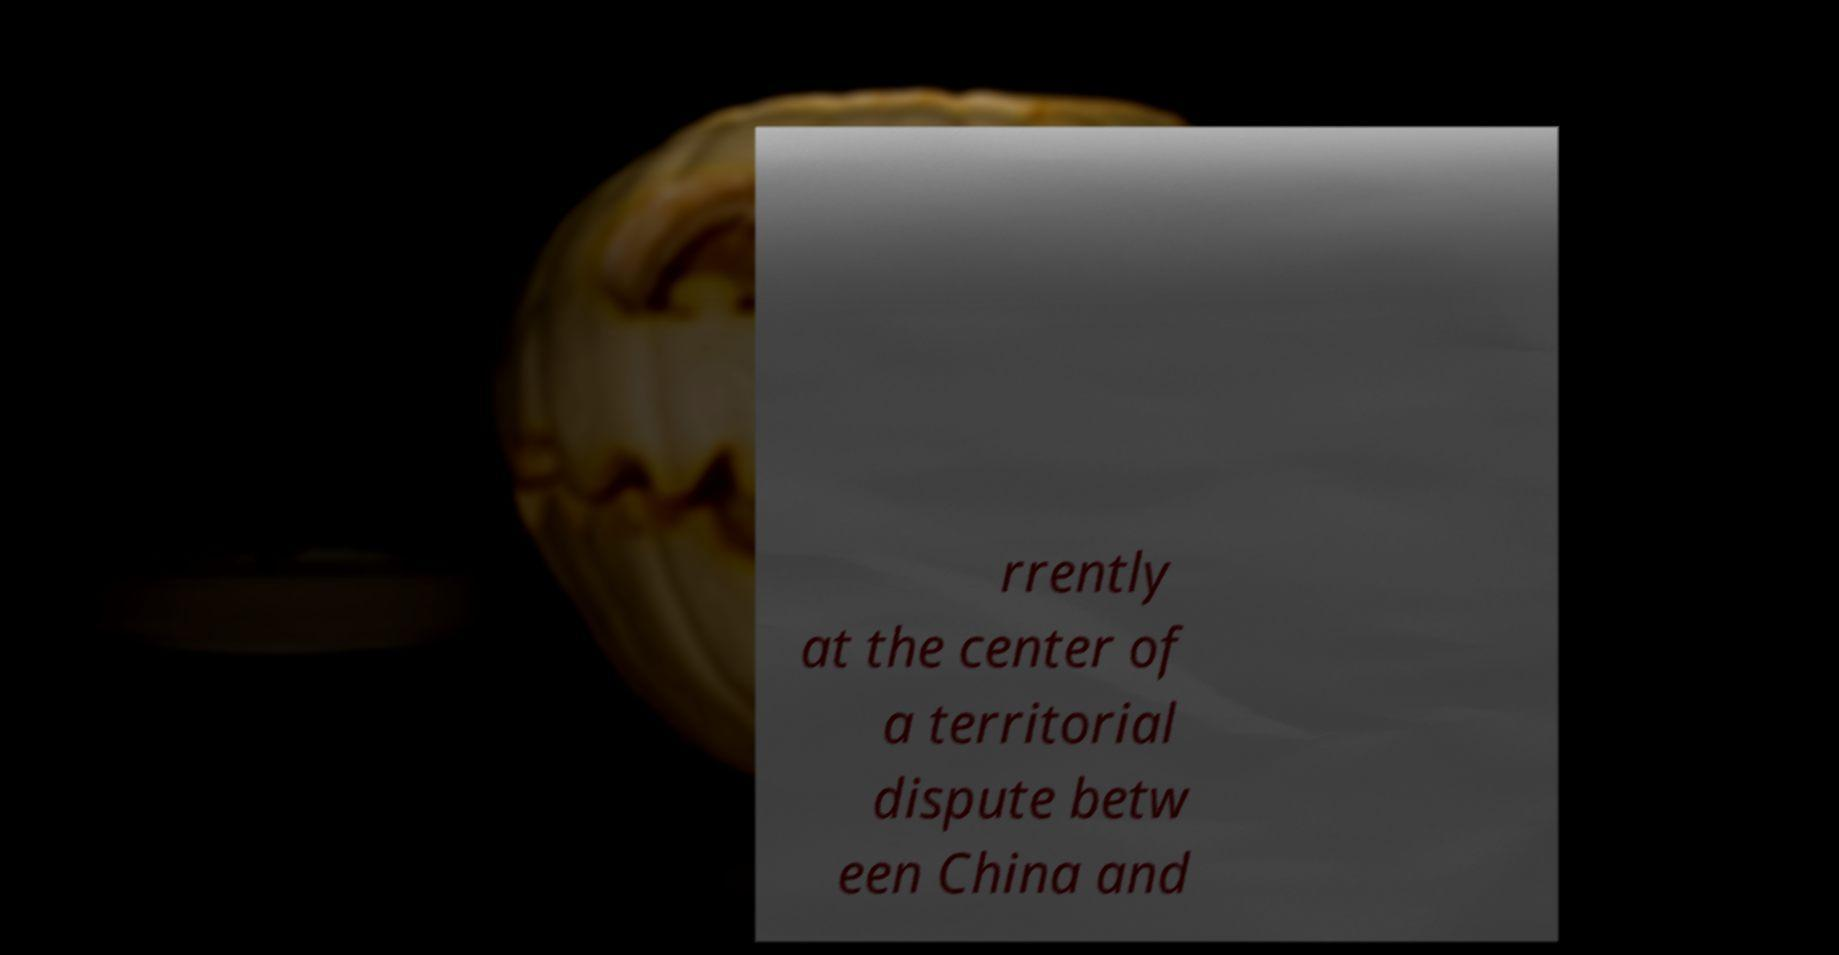There's text embedded in this image that I need extracted. Can you transcribe it verbatim? rrently at the center of a territorial dispute betw een China and 